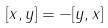<formula> <loc_0><loc_0><loc_500><loc_500>[ x , y ] = - [ y , x ]</formula> 